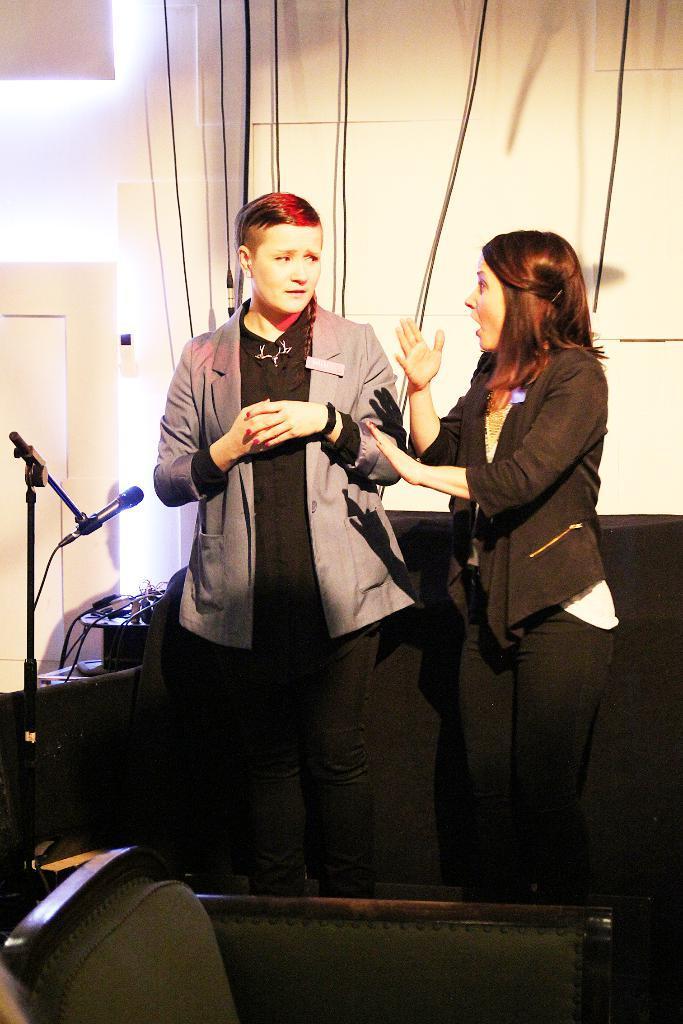Could you give a brief overview of what you see in this image? In this image we can see two persons are standing. There is a mike, chair, and cables. In the background we can see wall, wires, and a door. 